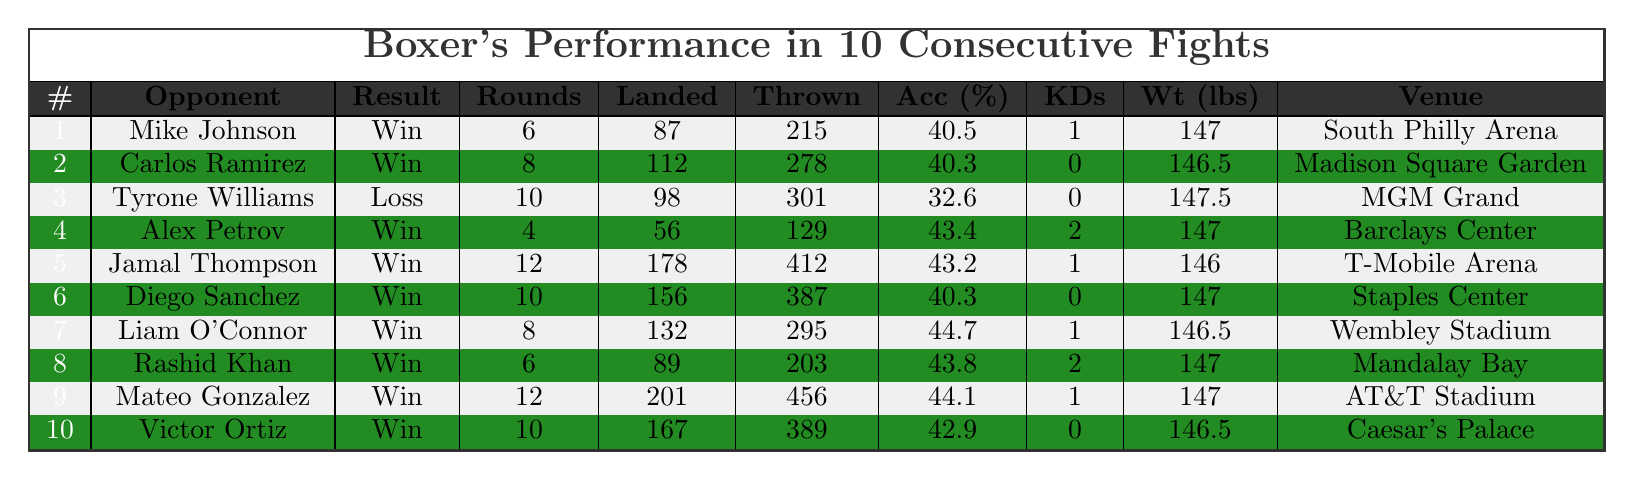What was the result of the fight against Tyrone Williams? According to the table, the result of the fight against Tyrone Williams was a "Loss."
Answer: Loss How many rounds did the fight against Jamal Thompson last? The fight against Jamal Thompson lasted for 12 rounds, as indicated in the table.
Answer: 12 What was the highest accuracy percentage achieved in these fights? The highest accuracy percentage listed in the table is 44.7%, achieved in the fight against Liam O’Connor.
Answer: 44.7% Which opponent had the most punches landed? The opponent with the most punches landed was Mateo Gonzalez, with a total of 201 punches landed.
Answer: Mateo Gonzalez Did the boxer score any knockdowns in the fight against Diego Sanchez? No, the table clearly states that there were 0 knockdowns scored in the fight against Diego Sanchez.
Answer: No What is the average weight of the boxer over these fights? To find the average weight, sum the weights: 147 + 146.5 + 147.5 + 147 + 146 + 146.5 + 147 + 147 + 147 + 146.5 = 1467.5. Dividing by 10 gives an average weight of 146.75 lbs.
Answer: 146.75 How many total punches were thrown across all fights? The total punches thrown can be calculated by summing the "Punches Thrown" column: 215 + 278 + 301 + 129 + 412 + 387 + 295 + 203 + 456 + 389 = 3080.
Answer: 3080 In how many fights did the boxer achieve a knockdown? The boxer achieved knockdowns in 4 out of 10 fights: against Mike Johnson, Alex Petrov, Liam O’Connor, and Rashid Khan as shown in the table.
Answer: 4 Which venue hosted the fight against Rashid Khan? The venue for the fight against Rashid Khan was Mandalay Bay, as indicated in the table.
Answer: Mandalay Bay What percentage of fights resulted in wins? There are 9 wins out of 10 fights total, so the percentage is (9/10) * 100 = 90%.
Answer: 90% How does the accuracy in the fight against Alex Petrov compare to that against Diego Sanchez? The accuracy against Alex Petrov was 43.4%, while against Diego Sanchez it was 40.3%. 43.4% is higher than 40.3%.
Answer: Higher 